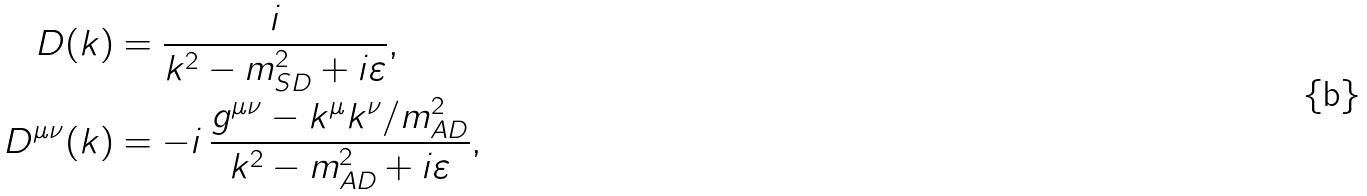Convert formula to latex. <formula><loc_0><loc_0><loc_500><loc_500>D ( k ) & = \frac { i } { k ^ { 2 } - m _ { S D } ^ { 2 } + i \varepsilon } , \\ D ^ { \mu \nu } ( k ) & = - i \, \frac { g ^ { \mu \nu } - k ^ { \mu } k ^ { \nu } / m _ { A D } ^ { 2 } } { k ^ { 2 } - m _ { A D } ^ { 2 } + i \varepsilon } ,</formula> 